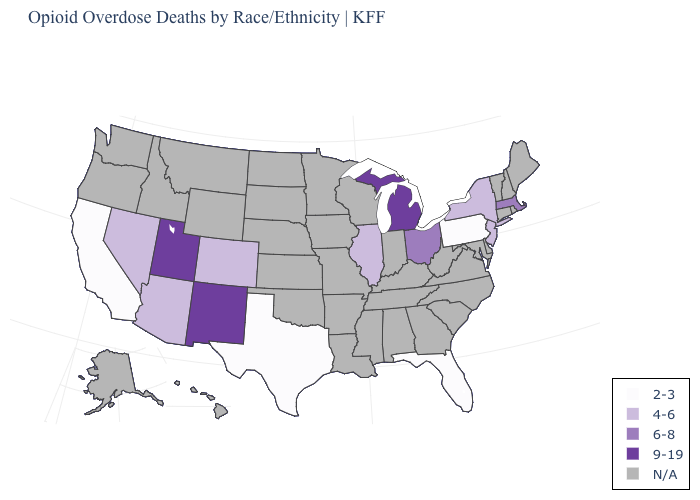What is the value of New Jersey?
Write a very short answer. 4-6. How many symbols are there in the legend?
Short answer required. 5. What is the value of North Carolina?
Write a very short answer. N/A. What is the lowest value in the South?
Concise answer only. 2-3. Name the states that have a value in the range N/A?
Quick response, please. Alabama, Alaska, Arkansas, Connecticut, Delaware, Georgia, Hawaii, Idaho, Indiana, Iowa, Kansas, Kentucky, Louisiana, Maine, Maryland, Minnesota, Mississippi, Missouri, Montana, Nebraska, New Hampshire, North Carolina, North Dakota, Oklahoma, Oregon, Rhode Island, South Carolina, South Dakota, Tennessee, Vermont, Virginia, Washington, West Virginia, Wisconsin, Wyoming. What is the value of South Dakota?
Be succinct. N/A. What is the lowest value in the USA?
Concise answer only. 2-3. Is the legend a continuous bar?
Answer briefly. No. What is the lowest value in the USA?
Concise answer only. 2-3. What is the value of Alaska?
Answer briefly. N/A. What is the highest value in the USA?
Be succinct. 9-19. Among the states that border Idaho , which have the highest value?
Be succinct. Utah. Which states hav the highest value in the South?
Keep it brief. Florida, Texas. Which states have the highest value in the USA?
Write a very short answer. Michigan, New Mexico, Utah. 